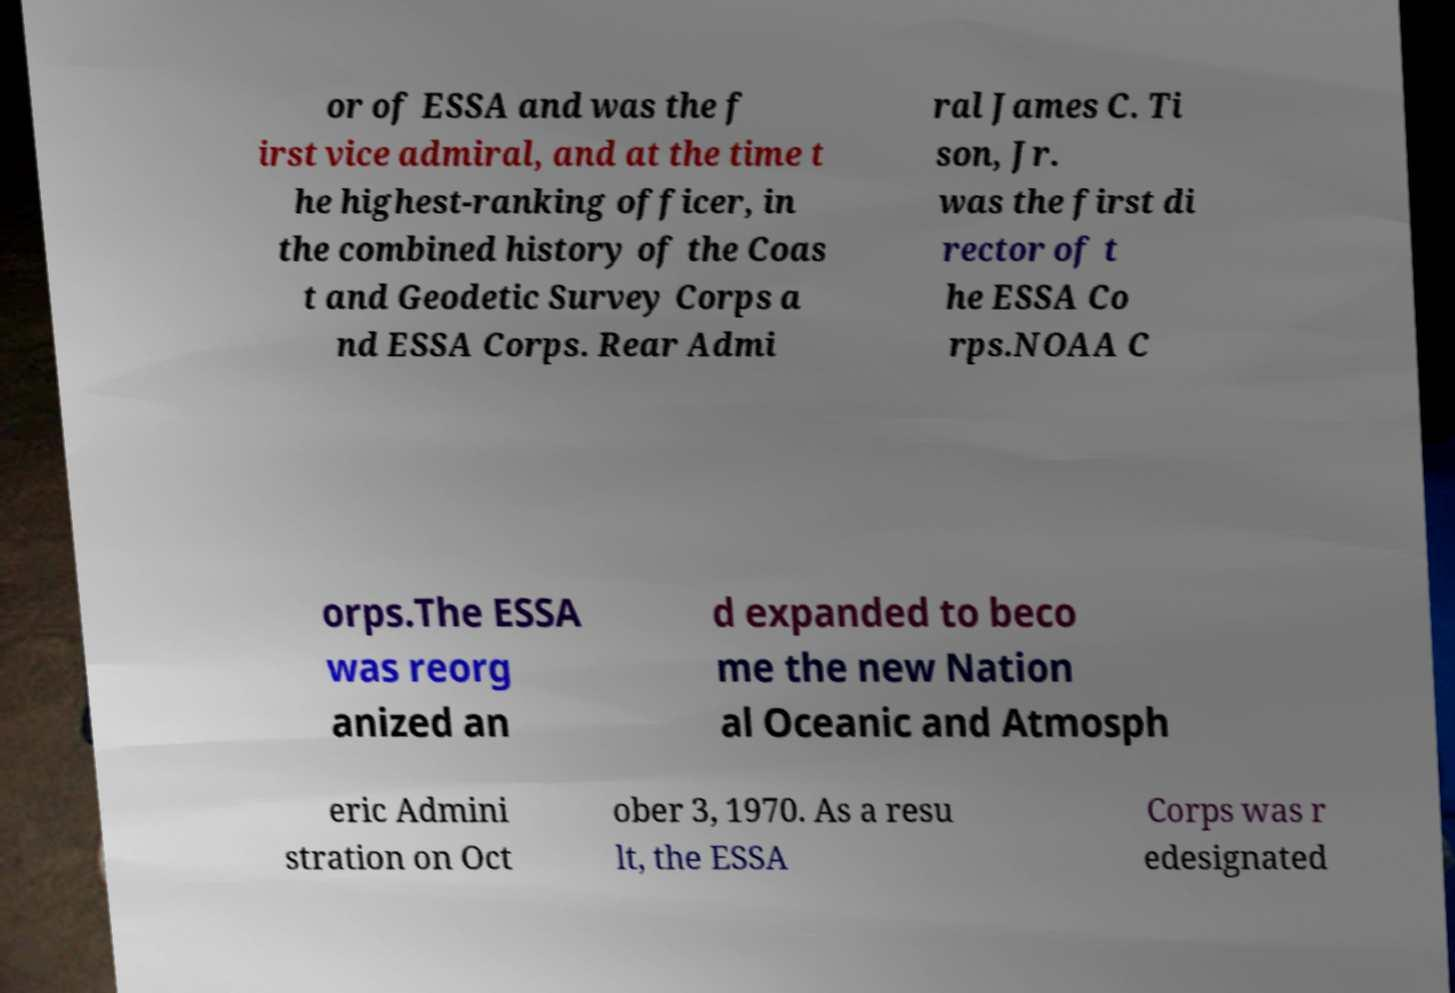Could you assist in decoding the text presented in this image and type it out clearly? or of ESSA and was the f irst vice admiral, and at the time t he highest-ranking officer, in the combined history of the Coas t and Geodetic Survey Corps a nd ESSA Corps. Rear Admi ral James C. Ti son, Jr. was the first di rector of t he ESSA Co rps.NOAA C orps.The ESSA was reorg anized an d expanded to beco me the new Nation al Oceanic and Atmosph eric Admini stration on Oct ober 3, 1970. As a resu lt, the ESSA Corps was r edesignated 